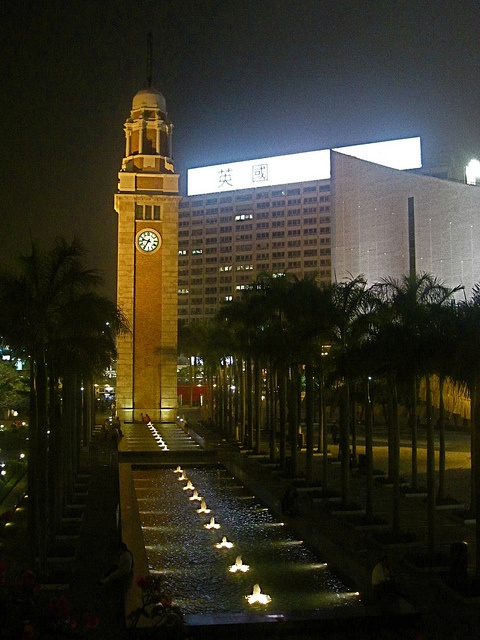Describe the objects in this image and their specific colors. I can see a clock in black, ivory, khaki, olive, and gray tones in this image. 